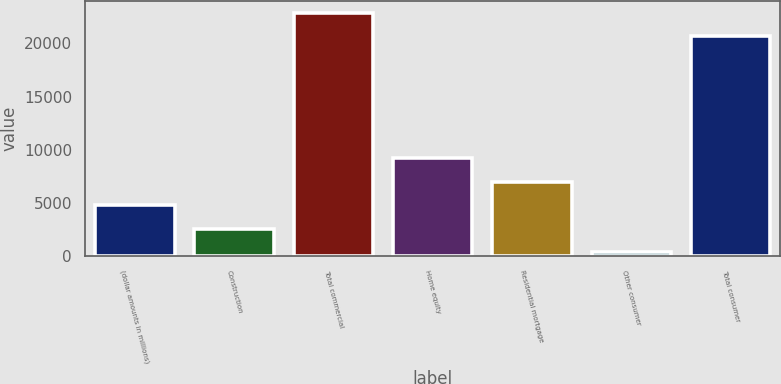<chart> <loc_0><loc_0><loc_500><loc_500><bar_chart><fcel>(dollar amounts in millions)<fcel>Construction<fcel>Total commercial<fcel>Home equity<fcel>Residential mortgage<fcel>Other consumer<fcel>Total consumer<nl><fcel>4792.8<fcel>2586.4<fcel>22882.4<fcel>9205.6<fcel>6999.2<fcel>380<fcel>20676<nl></chart> 